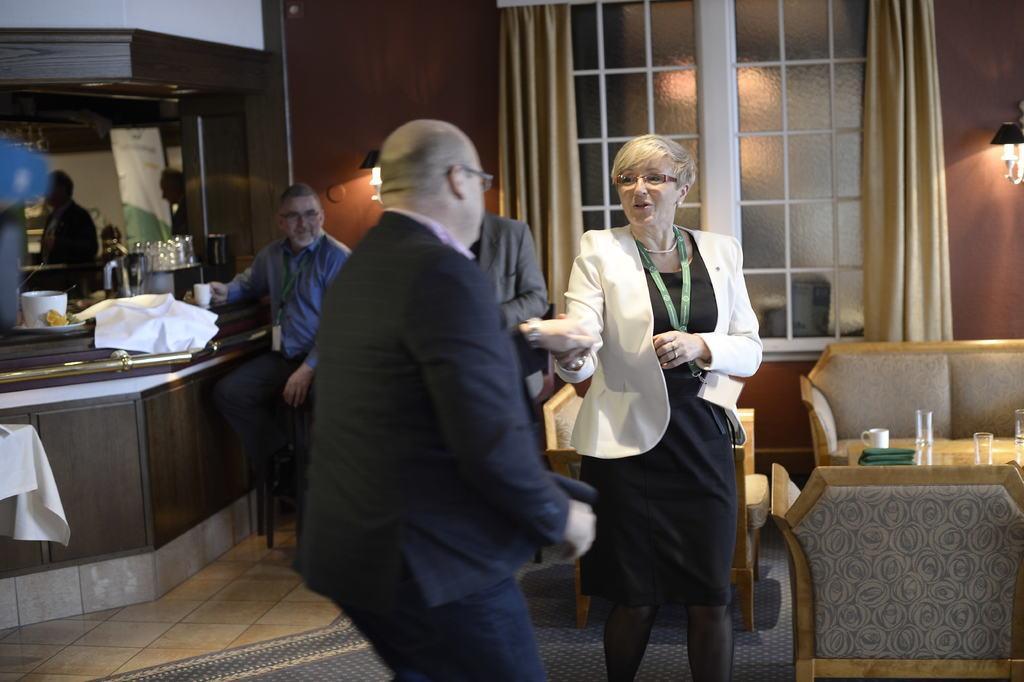Can you describe this image briefly? This is the man and woman standing. These are the chairs. I can see a table with a cup, glasses and a cloth. Here is a person sitting on the stool. These are the curtains hanging to the hanger. This looks like a window with a glass door. I can see a lamp, which is attached to the wall. I can see a cup, glasses and few other things are placed on the table. Here is a person standing. 